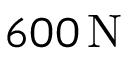<formula> <loc_0><loc_0><loc_500><loc_500>6 0 0 \, N</formula> 